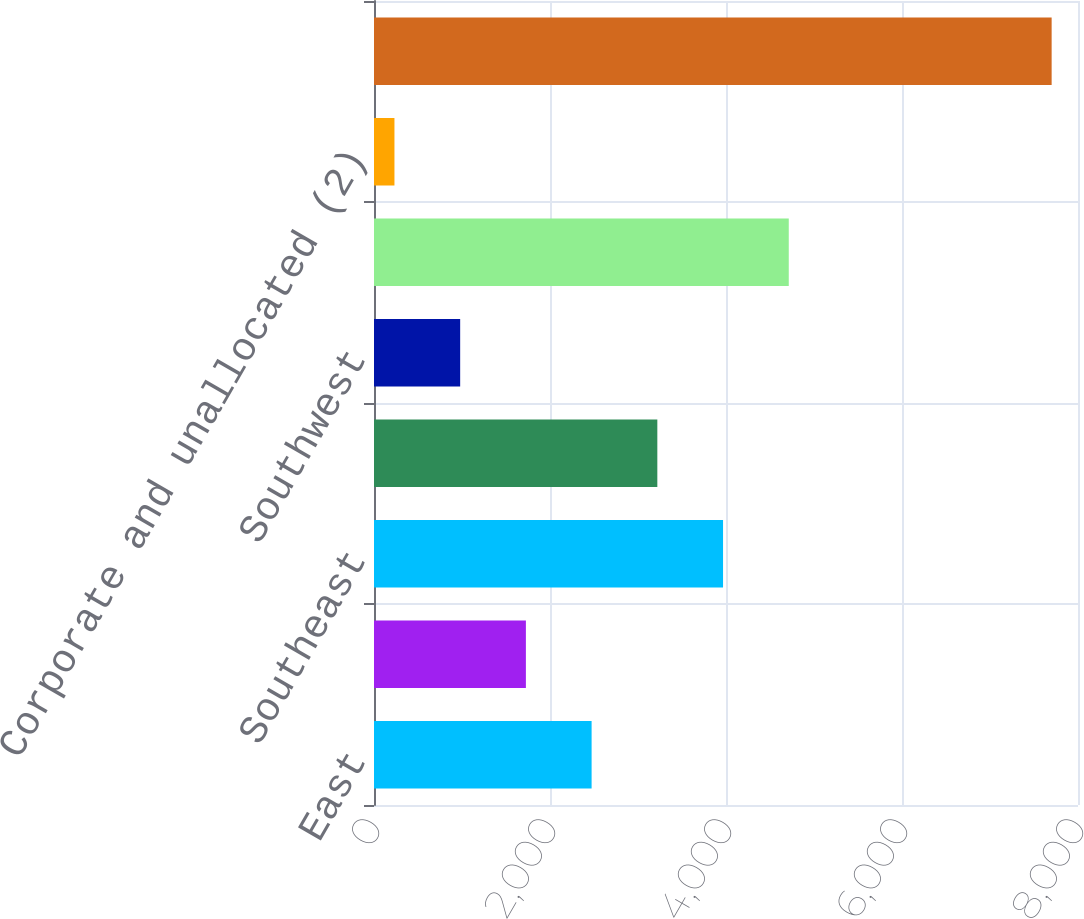<chart> <loc_0><loc_0><loc_500><loc_500><bar_chart><fcel>East<fcel>Midwest<fcel>Southeast<fcel>South Central<fcel>Southwest<fcel>West<fcel>Corporate and unallocated (2)<fcel>Total homebuilding inventories<nl><fcel>2472.83<fcel>1726.02<fcel>3966.45<fcel>3219.64<fcel>979.21<fcel>4713.26<fcel>232.4<fcel>7700.5<nl></chart> 